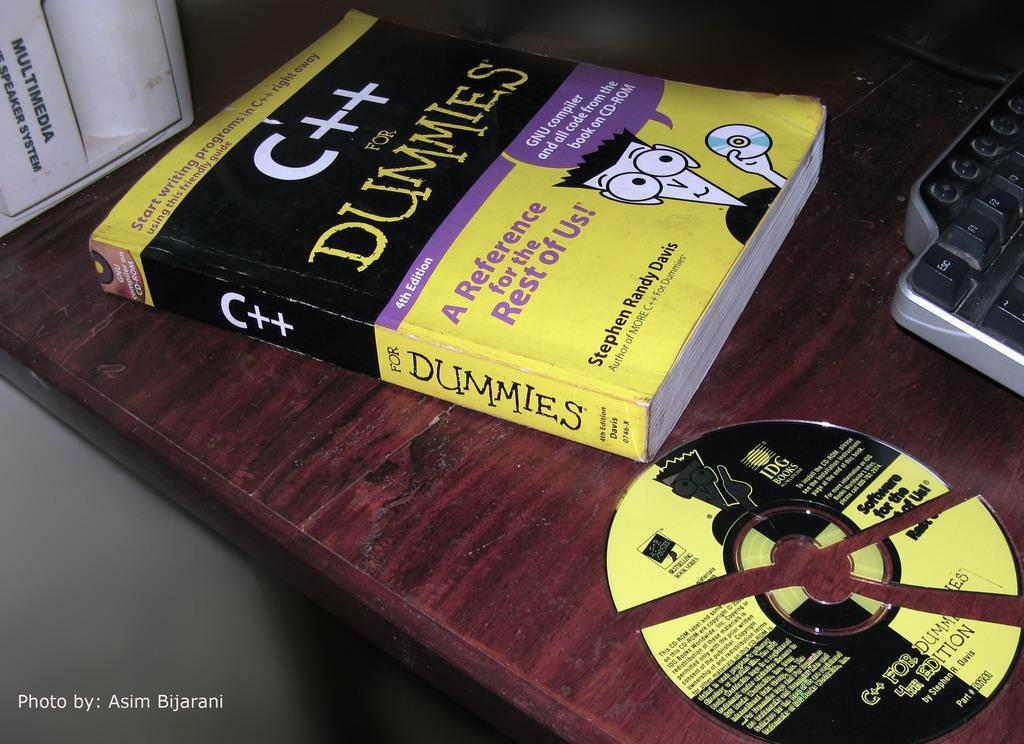<image>
Give a short and clear explanation of the subsequent image. The fourth edition of a Dummies book is on a table. 